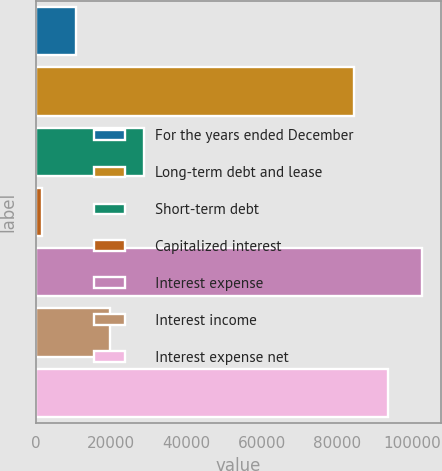Convert chart. <chart><loc_0><loc_0><loc_500><loc_500><bar_chart><fcel>For the years ended December<fcel>Long-term debt and lease<fcel>Short-term debt<fcel>Capitalized interest<fcel>Interest expense<fcel>Interest income<fcel>Interest expense net<nl><fcel>10721<fcel>84604<fcel>28675<fcel>1744<fcel>102558<fcel>19698<fcel>93581<nl></chart> 